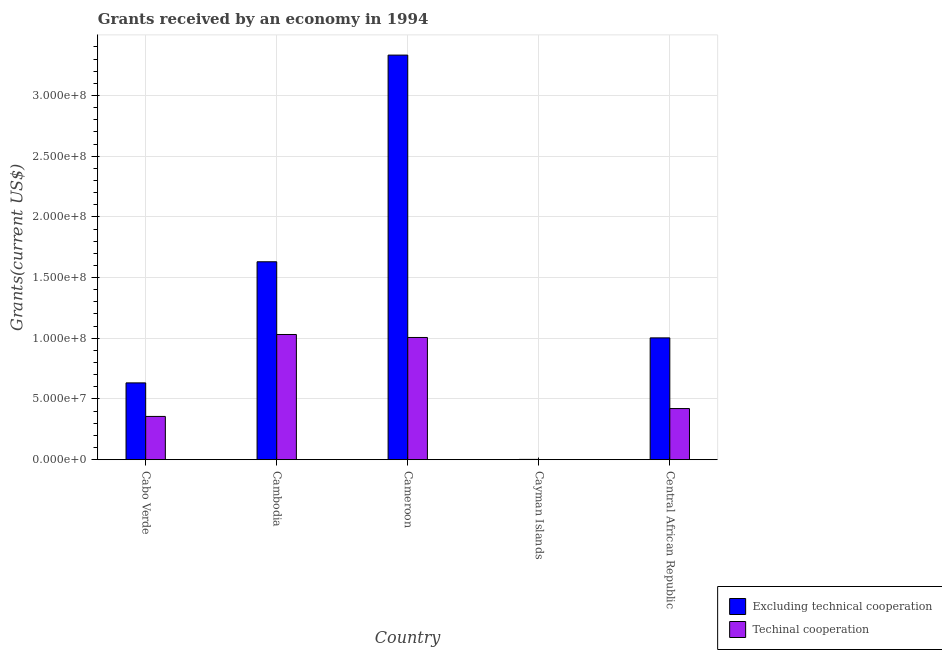How many different coloured bars are there?
Your answer should be compact. 2. How many groups of bars are there?
Ensure brevity in your answer.  5. Are the number of bars on each tick of the X-axis equal?
Provide a succinct answer. Yes. How many bars are there on the 3rd tick from the left?
Your answer should be compact. 2. What is the label of the 5th group of bars from the left?
Ensure brevity in your answer.  Central African Republic. In how many cases, is the number of bars for a given country not equal to the number of legend labels?
Provide a succinct answer. 0. What is the amount of grants received(including technical cooperation) in Cambodia?
Provide a succinct answer. 1.03e+08. Across all countries, what is the maximum amount of grants received(excluding technical cooperation)?
Keep it short and to the point. 3.33e+08. Across all countries, what is the minimum amount of grants received(including technical cooperation)?
Your response must be concise. 6.00e+04. In which country was the amount of grants received(including technical cooperation) maximum?
Give a very brief answer. Cambodia. In which country was the amount of grants received(excluding technical cooperation) minimum?
Provide a short and direct response. Cayman Islands. What is the total amount of grants received(including technical cooperation) in the graph?
Ensure brevity in your answer.  2.82e+08. What is the difference between the amount of grants received(including technical cooperation) in Cabo Verde and that in Cayman Islands?
Provide a short and direct response. 3.56e+07. What is the difference between the amount of grants received(including technical cooperation) in Cayman Islands and the amount of grants received(excluding technical cooperation) in Cabo Verde?
Your answer should be very brief. -6.32e+07. What is the average amount of grants received(excluding technical cooperation) per country?
Provide a short and direct response. 1.32e+08. What is the difference between the amount of grants received(excluding technical cooperation) and amount of grants received(including technical cooperation) in Cabo Verde?
Your response must be concise. 2.76e+07. In how many countries, is the amount of grants received(excluding technical cooperation) greater than 200000000 US$?
Your answer should be compact. 1. What is the ratio of the amount of grants received(including technical cooperation) in Cabo Verde to that in Central African Republic?
Offer a terse response. 0.85. Is the amount of grants received(excluding technical cooperation) in Cabo Verde less than that in Cambodia?
Give a very brief answer. Yes. What is the difference between the highest and the second highest amount of grants received(including technical cooperation)?
Offer a terse response. 2.46e+06. What is the difference between the highest and the lowest amount of grants received(including technical cooperation)?
Provide a short and direct response. 1.03e+08. In how many countries, is the amount of grants received(excluding technical cooperation) greater than the average amount of grants received(excluding technical cooperation) taken over all countries?
Offer a terse response. 2. Is the sum of the amount of grants received(excluding technical cooperation) in Cabo Verde and Cambodia greater than the maximum amount of grants received(including technical cooperation) across all countries?
Offer a terse response. Yes. What does the 1st bar from the left in Central African Republic represents?
Provide a short and direct response. Excluding technical cooperation. What does the 1st bar from the right in Cameroon represents?
Your answer should be compact. Techinal cooperation. How many bars are there?
Offer a very short reply. 10. How many countries are there in the graph?
Offer a terse response. 5. Does the graph contain any zero values?
Make the answer very short. No. How many legend labels are there?
Your answer should be very brief. 2. How are the legend labels stacked?
Give a very brief answer. Vertical. What is the title of the graph?
Ensure brevity in your answer.  Grants received by an economy in 1994. What is the label or title of the Y-axis?
Give a very brief answer. Grants(current US$). What is the Grants(current US$) in Excluding technical cooperation in Cabo Verde?
Make the answer very short. 6.33e+07. What is the Grants(current US$) in Techinal cooperation in Cabo Verde?
Your response must be concise. 3.56e+07. What is the Grants(current US$) of Excluding technical cooperation in Cambodia?
Your answer should be compact. 1.63e+08. What is the Grants(current US$) of Techinal cooperation in Cambodia?
Offer a very short reply. 1.03e+08. What is the Grants(current US$) in Excluding technical cooperation in Cameroon?
Your answer should be compact. 3.33e+08. What is the Grants(current US$) of Techinal cooperation in Cameroon?
Your answer should be very brief. 1.01e+08. What is the Grants(current US$) of Excluding technical cooperation in Cayman Islands?
Your answer should be compact. 2.50e+05. What is the Grants(current US$) of Excluding technical cooperation in Central African Republic?
Offer a very short reply. 1.00e+08. What is the Grants(current US$) of Techinal cooperation in Central African Republic?
Keep it short and to the point. 4.21e+07. Across all countries, what is the maximum Grants(current US$) of Excluding technical cooperation?
Keep it short and to the point. 3.33e+08. Across all countries, what is the maximum Grants(current US$) in Techinal cooperation?
Keep it short and to the point. 1.03e+08. Across all countries, what is the minimum Grants(current US$) in Excluding technical cooperation?
Your answer should be very brief. 2.50e+05. Across all countries, what is the minimum Grants(current US$) in Techinal cooperation?
Provide a succinct answer. 6.00e+04. What is the total Grants(current US$) of Excluding technical cooperation in the graph?
Your answer should be very brief. 6.60e+08. What is the total Grants(current US$) in Techinal cooperation in the graph?
Provide a succinct answer. 2.82e+08. What is the difference between the Grants(current US$) of Excluding technical cooperation in Cabo Verde and that in Cambodia?
Your response must be concise. -9.98e+07. What is the difference between the Grants(current US$) in Techinal cooperation in Cabo Verde and that in Cambodia?
Ensure brevity in your answer.  -6.75e+07. What is the difference between the Grants(current US$) of Excluding technical cooperation in Cabo Verde and that in Cameroon?
Offer a terse response. -2.70e+08. What is the difference between the Grants(current US$) in Techinal cooperation in Cabo Verde and that in Cameroon?
Offer a very short reply. -6.50e+07. What is the difference between the Grants(current US$) of Excluding technical cooperation in Cabo Verde and that in Cayman Islands?
Your answer should be very brief. 6.30e+07. What is the difference between the Grants(current US$) of Techinal cooperation in Cabo Verde and that in Cayman Islands?
Offer a very short reply. 3.56e+07. What is the difference between the Grants(current US$) of Excluding technical cooperation in Cabo Verde and that in Central African Republic?
Provide a succinct answer. -3.71e+07. What is the difference between the Grants(current US$) in Techinal cooperation in Cabo Verde and that in Central African Republic?
Your answer should be very brief. -6.48e+06. What is the difference between the Grants(current US$) of Excluding technical cooperation in Cambodia and that in Cameroon?
Provide a succinct answer. -1.70e+08. What is the difference between the Grants(current US$) in Techinal cooperation in Cambodia and that in Cameroon?
Your answer should be compact. 2.46e+06. What is the difference between the Grants(current US$) in Excluding technical cooperation in Cambodia and that in Cayman Islands?
Offer a very short reply. 1.63e+08. What is the difference between the Grants(current US$) of Techinal cooperation in Cambodia and that in Cayman Islands?
Your answer should be very brief. 1.03e+08. What is the difference between the Grants(current US$) of Excluding technical cooperation in Cambodia and that in Central African Republic?
Your answer should be compact. 6.27e+07. What is the difference between the Grants(current US$) in Techinal cooperation in Cambodia and that in Central African Republic?
Keep it short and to the point. 6.10e+07. What is the difference between the Grants(current US$) of Excluding technical cooperation in Cameroon and that in Cayman Islands?
Give a very brief answer. 3.33e+08. What is the difference between the Grants(current US$) in Techinal cooperation in Cameroon and that in Cayman Islands?
Keep it short and to the point. 1.01e+08. What is the difference between the Grants(current US$) of Excluding technical cooperation in Cameroon and that in Central African Republic?
Give a very brief answer. 2.33e+08. What is the difference between the Grants(current US$) in Techinal cooperation in Cameroon and that in Central African Republic?
Provide a succinct answer. 5.85e+07. What is the difference between the Grants(current US$) in Excluding technical cooperation in Cayman Islands and that in Central African Republic?
Ensure brevity in your answer.  -1.00e+08. What is the difference between the Grants(current US$) in Techinal cooperation in Cayman Islands and that in Central African Republic?
Give a very brief answer. -4.21e+07. What is the difference between the Grants(current US$) in Excluding technical cooperation in Cabo Verde and the Grants(current US$) in Techinal cooperation in Cambodia?
Your answer should be compact. -3.99e+07. What is the difference between the Grants(current US$) in Excluding technical cooperation in Cabo Verde and the Grants(current US$) in Techinal cooperation in Cameroon?
Your response must be concise. -3.74e+07. What is the difference between the Grants(current US$) in Excluding technical cooperation in Cabo Verde and the Grants(current US$) in Techinal cooperation in Cayman Islands?
Offer a very short reply. 6.32e+07. What is the difference between the Grants(current US$) of Excluding technical cooperation in Cabo Verde and the Grants(current US$) of Techinal cooperation in Central African Republic?
Provide a succinct answer. 2.11e+07. What is the difference between the Grants(current US$) of Excluding technical cooperation in Cambodia and the Grants(current US$) of Techinal cooperation in Cameroon?
Provide a succinct answer. 6.24e+07. What is the difference between the Grants(current US$) of Excluding technical cooperation in Cambodia and the Grants(current US$) of Techinal cooperation in Cayman Islands?
Keep it short and to the point. 1.63e+08. What is the difference between the Grants(current US$) in Excluding technical cooperation in Cambodia and the Grants(current US$) in Techinal cooperation in Central African Republic?
Your response must be concise. 1.21e+08. What is the difference between the Grants(current US$) in Excluding technical cooperation in Cameroon and the Grants(current US$) in Techinal cooperation in Cayman Islands?
Keep it short and to the point. 3.33e+08. What is the difference between the Grants(current US$) in Excluding technical cooperation in Cameroon and the Grants(current US$) in Techinal cooperation in Central African Republic?
Your answer should be compact. 2.91e+08. What is the difference between the Grants(current US$) in Excluding technical cooperation in Cayman Islands and the Grants(current US$) in Techinal cooperation in Central African Republic?
Make the answer very short. -4.19e+07. What is the average Grants(current US$) in Excluding technical cooperation per country?
Ensure brevity in your answer.  1.32e+08. What is the average Grants(current US$) of Techinal cooperation per country?
Ensure brevity in your answer.  5.63e+07. What is the difference between the Grants(current US$) of Excluding technical cooperation and Grants(current US$) of Techinal cooperation in Cabo Verde?
Your answer should be compact. 2.76e+07. What is the difference between the Grants(current US$) in Excluding technical cooperation and Grants(current US$) in Techinal cooperation in Cambodia?
Provide a succinct answer. 5.99e+07. What is the difference between the Grants(current US$) of Excluding technical cooperation and Grants(current US$) of Techinal cooperation in Cameroon?
Offer a very short reply. 2.33e+08. What is the difference between the Grants(current US$) of Excluding technical cooperation and Grants(current US$) of Techinal cooperation in Central African Republic?
Provide a succinct answer. 5.82e+07. What is the ratio of the Grants(current US$) in Excluding technical cooperation in Cabo Verde to that in Cambodia?
Provide a succinct answer. 0.39. What is the ratio of the Grants(current US$) in Techinal cooperation in Cabo Verde to that in Cambodia?
Your answer should be compact. 0.35. What is the ratio of the Grants(current US$) of Excluding technical cooperation in Cabo Verde to that in Cameroon?
Offer a terse response. 0.19. What is the ratio of the Grants(current US$) in Techinal cooperation in Cabo Verde to that in Cameroon?
Offer a terse response. 0.35. What is the ratio of the Grants(current US$) in Excluding technical cooperation in Cabo Verde to that in Cayman Islands?
Offer a terse response. 253.04. What is the ratio of the Grants(current US$) in Techinal cooperation in Cabo Verde to that in Cayman Islands?
Your answer should be very brief. 594. What is the ratio of the Grants(current US$) of Excluding technical cooperation in Cabo Verde to that in Central African Republic?
Make the answer very short. 0.63. What is the ratio of the Grants(current US$) of Techinal cooperation in Cabo Verde to that in Central African Republic?
Give a very brief answer. 0.85. What is the ratio of the Grants(current US$) of Excluding technical cooperation in Cambodia to that in Cameroon?
Ensure brevity in your answer.  0.49. What is the ratio of the Grants(current US$) in Techinal cooperation in Cambodia to that in Cameroon?
Provide a short and direct response. 1.02. What is the ratio of the Grants(current US$) of Excluding technical cooperation in Cambodia to that in Cayman Islands?
Ensure brevity in your answer.  652.04. What is the ratio of the Grants(current US$) in Techinal cooperation in Cambodia to that in Cayman Islands?
Your response must be concise. 1718.67. What is the ratio of the Grants(current US$) in Excluding technical cooperation in Cambodia to that in Central African Republic?
Keep it short and to the point. 1.62. What is the ratio of the Grants(current US$) in Techinal cooperation in Cambodia to that in Central African Republic?
Provide a short and direct response. 2.45. What is the ratio of the Grants(current US$) of Excluding technical cooperation in Cameroon to that in Cayman Islands?
Provide a short and direct response. 1332.92. What is the ratio of the Grants(current US$) in Techinal cooperation in Cameroon to that in Cayman Islands?
Offer a very short reply. 1677.67. What is the ratio of the Grants(current US$) of Excluding technical cooperation in Cameroon to that in Central African Republic?
Offer a terse response. 3.32. What is the ratio of the Grants(current US$) in Techinal cooperation in Cameroon to that in Central African Republic?
Offer a terse response. 2.39. What is the ratio of the Grants(current US$) of Excluding technical cooperation in Cayman Islands to that in Central African Republic?
Provide a succinct answer. 0. What is the ratio of the Grants(current US$) in Techinal cooperation in Cayman Islands to that in Central African Republic?
Keep it short and to the point. 0. What is the difference between the highest and the second highest Grants(current US$) of Excluding technical cooperation?
Offer a terse response. 1.70e+08. What is the difference between the highest and the second highest Grants(current US$) in Techinal cooperation?
Give a very brief answer. 2.46e+06. What is the difference between the highest and the lowest Grants(current US$) of Excluding technical cooperation?
Keep it short and to the point. 3.33e+08. What is the difference between the highest and the lowest Grants(current US$) in Techinal cooperation?
Provide a succinct answer. 1.03e+08. 